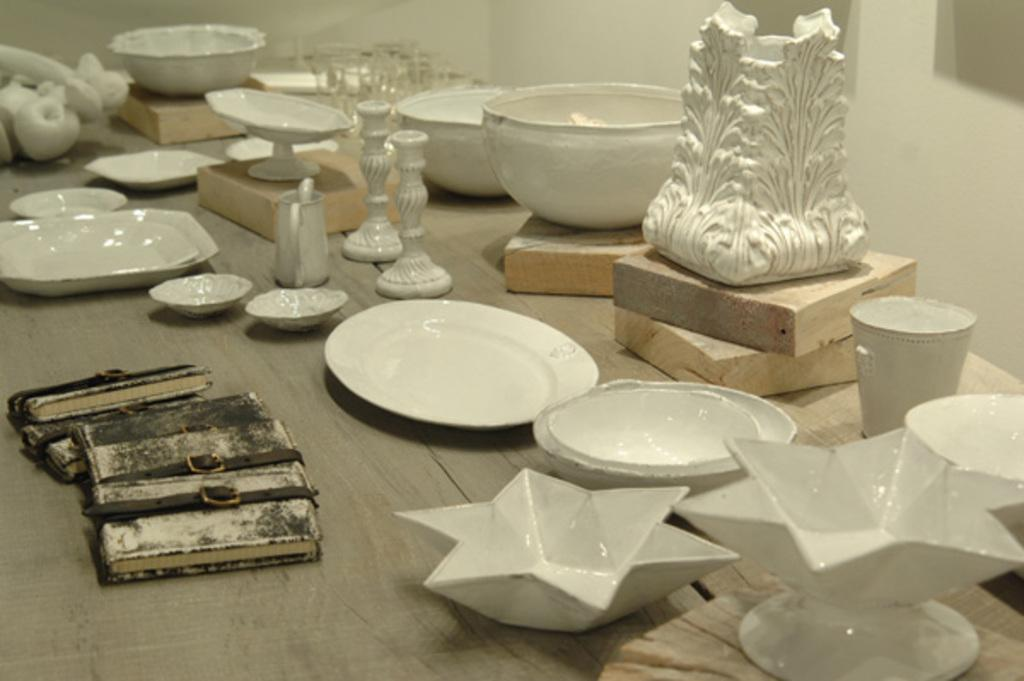What type of furniture is present in the image? There is a table in the image. What objects are placed on the table? There are plates, bowls, books, wooden boxes, and glasses on the table. What is the color of the items on the table? All the items on the table are in white color. What material are the plates, bowls, and glasses made of? The items are made of ceramic. Can you see any icicles hanging from the table in the image? No, there are no icicles present in the image. Are there any flowers on the table in the image? No, there are no flowers present in the image. 